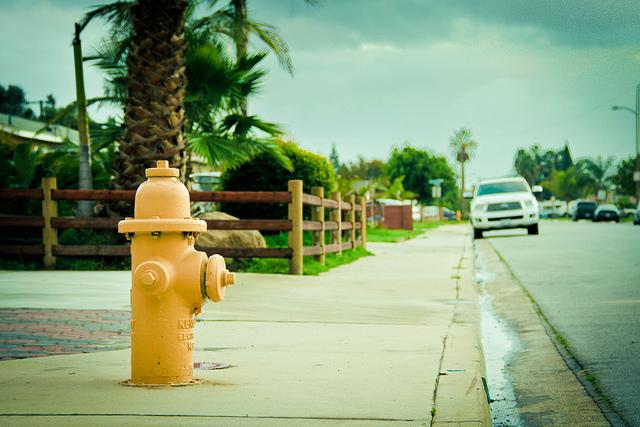What kind of weather is one likely to experience in this area? rainy 